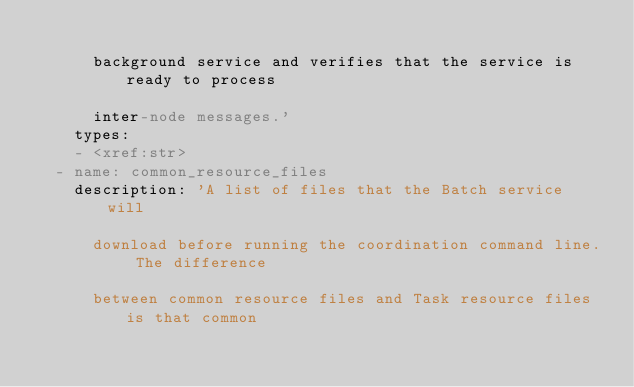<code> <loc_0><loc_0><loc_500><loc_500><_YAML_>
      background service and verifies that the service is ready to process

      inter-node messages.'
    types:
    - <xref:str>
  - name: common_resource_files
    description: 'A list of files that the Batch service will

      download before running the coordination command line. The difference

      between common resource files and Task resource files is that common
</code> 